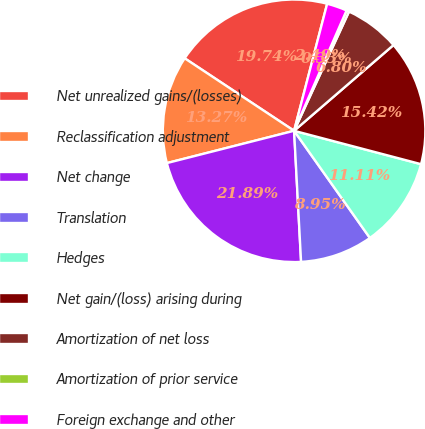<chart> <loc_0><loc_0><loc_500><loc_500><pie_chart><fcel>Net unrealized gains/(losses)<fcel>Reclassification adjustment<fcel>Net change<fcel>Translation<fcel>Hedges<fcel>Net gain/(loss) arising during<fcel>Amortization of net loss<fcel>Amortization of prior service<fcel>Foreign exchange and other<nl><fcel>19.74%<fcel>13.27%<fcel>21.89%<fcel>8.95%<fcel>11.11%<fcel>15.42%<fcel>6.8%<fcel>0.33%<fcel>2.49%<nl></chart> 